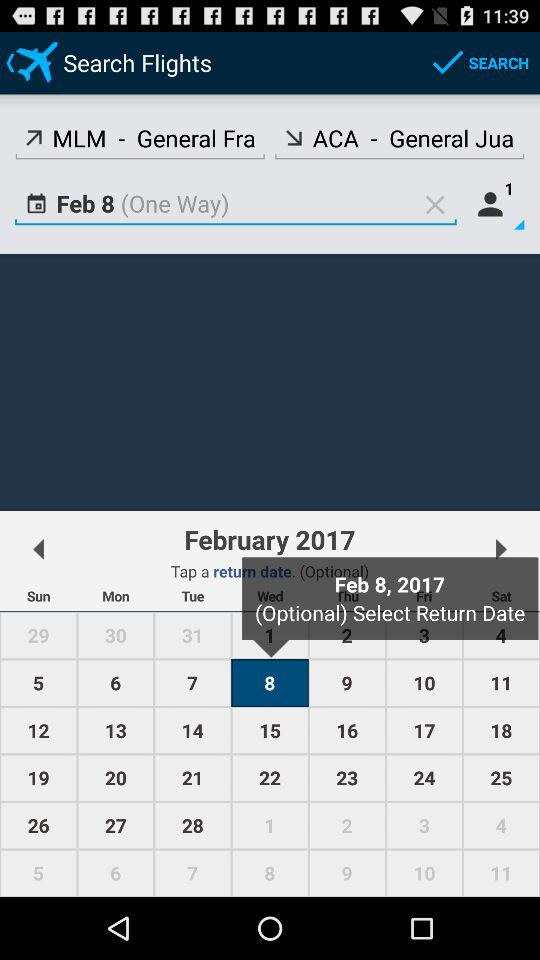How much is the total fare?
When the provided information is insufficient, respond with <no answer>. <no answer> 